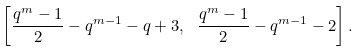Convert formula to latex. <formula><loc_0><loc_0><loc_500><loc_500>\left [ \frac { q ^ { m } - 1 } { 2 } - q ^ { m - 1 } - q + 3 , \ \frac { q ^ { m } - 1 } { 2 } - q ^ { m - 1 } - 2 \right ] .</formula> 